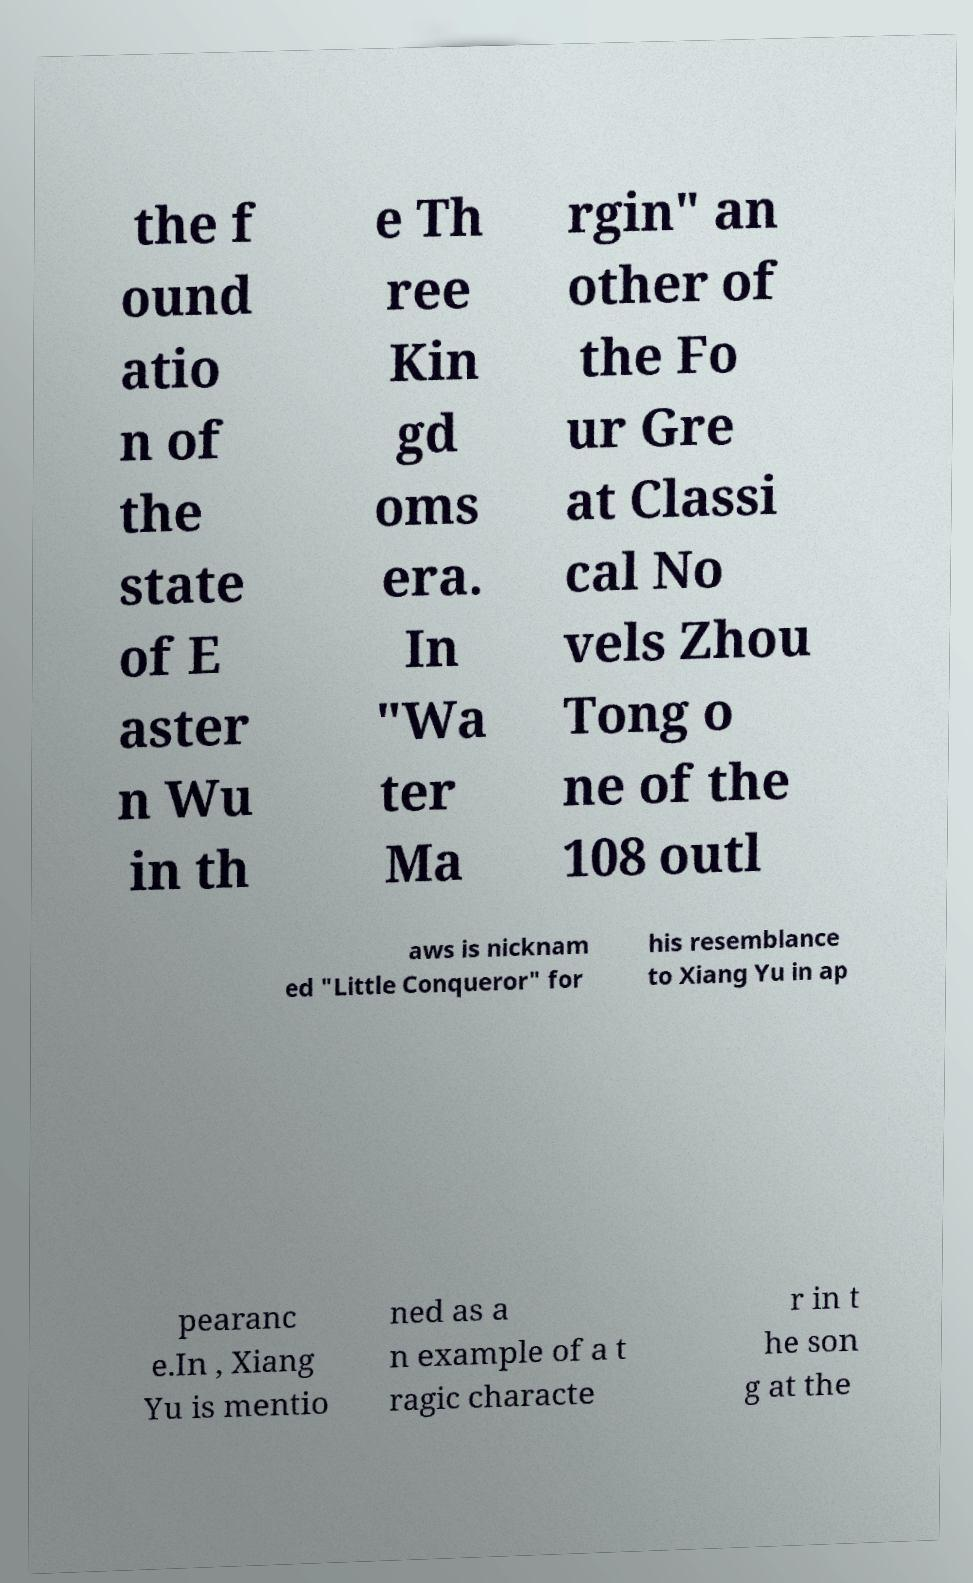For documentation purposes, I need the text within this image transcribed. Could you provide that? the f ound atio n of the state of E aster n Wu in th e Th ree Kin gd oms era. In "Wa ter Ma rgin" an other of the Fo ur Gre at Classi cal No vels Zhou Tong o ne of the 108 outl aws is nicknam ed "Little Conqueror" for his resemblance to Xiang Yu in ap pearanc e.In , Xiang Yu is mentio ned as a n example of a t ragic characte r in t he son g at the 